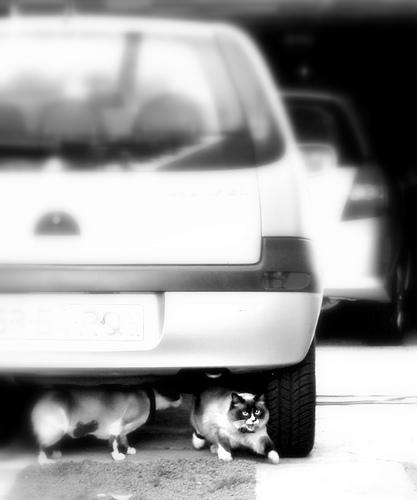How many cats are there?
Give a very brief answer. 2. How many cars can be seen?
Give a very brief answer. 2. 